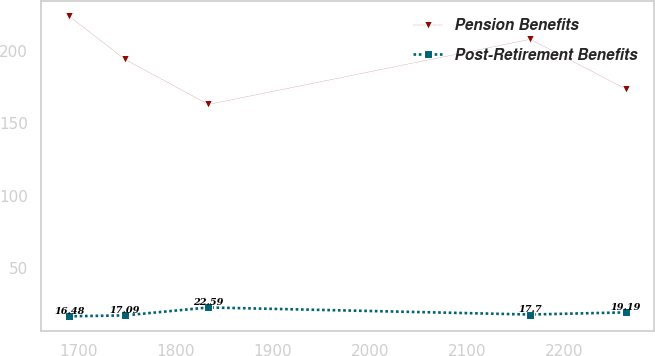Convert chart. <chart><loc_0><loc_0><loc_500><loc_500><line_chart><ecel><fcel>Pension Benefits<fcel>Post-Retirement Benefits<nl><fcel>1690.1<fcel>223.99<fcel>16.48<nl><fcel>1747.43<fcel>194.23<fcel>17.09<nl><fcel>1833.49<fcel>162.99<fcel>22.59<nl><fcel>2165.11<fcel>208.07<fcel>17.7<nl><fcel>2263.44<fcel>173.58<fcel>19.19<nl></chart> 